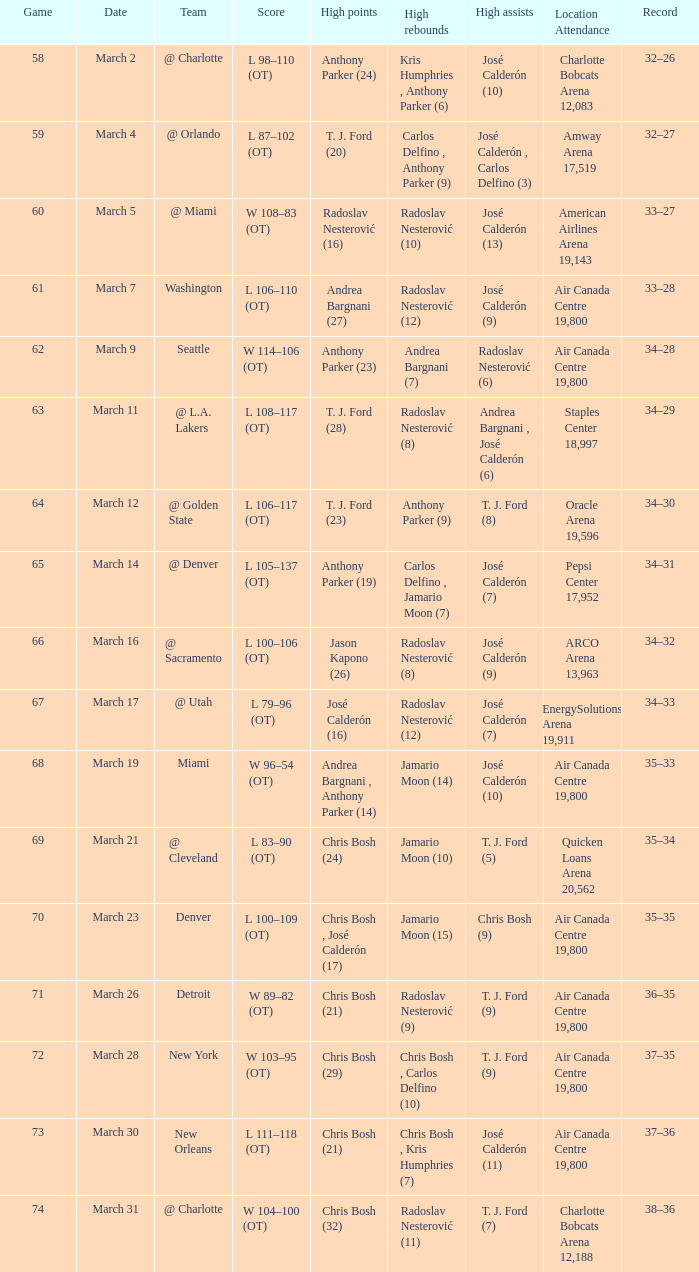How many people attended the event on march 16 after surpassing 64 games? ARCO Arena 13,963. 